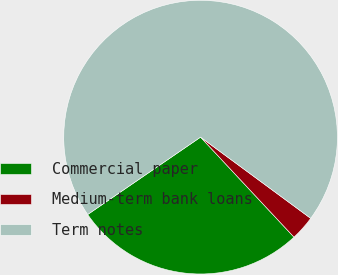Convert chart to OTSL. <chart><loc_0><loc_0><loc_500><loc_500><pie_chart><fcel>Commercial paper<fcel>Medium-term bank loans<fcel>Term notes<nl><fcel>27.4%<fcel>2.93%<fcel>69.68%<nl></chart> 